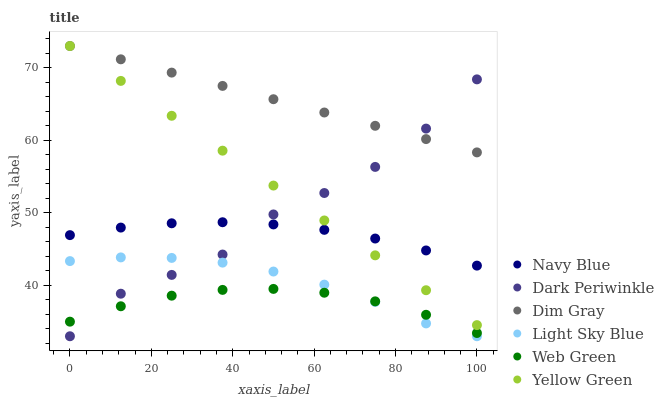Does Web Green have the minimum area under the curve?
Answer yes or no. Yes. Does Dim Gray have the maximum area under the curve?
Answer yes or no. Yes. Does Yellow Green have the minimum area under the curve?
Answer yes or no. No. Does Yellow Green have the maximum area under the curve?
Answer yes or no. No. Is Yellow Green the smoothest?
Answer yes or no. Yes. Is Dark Periwinkle the roughest?
Answer yes or no. Yes. Is Navy Blue the smoothest?
Answer yes or no. No. Is Navy Blue the roughest?
Answer yes or no. No. Does Light Sky Blue have the lowest value?
Answer yes or no. Yes. Does Yellow Green have the lowest value?
Answer yes or no. No. Does Yellow Green have the highest value?
Answer yes or no. Yes. Does Navy Blue have the highest value?
Answer yes or no. No. Is Web Green less than Dim Gray?
Answer yes or no. Yes. Is Navy Blue greater than Light Sky Blue?
Answer yes or no. Yes. Does Dark Periwinkle intersect Light Sky Blue?
Answer yes or no. Yes. Is Dark Periwinkle less than Light Sky Blue?
Answer yes or no. No. Is Dark Periwinkle greater than Light Sky Blue?
Answer yes or no. No. Does Web Green intersect Dim Gray?
Answer yes or no. No. 